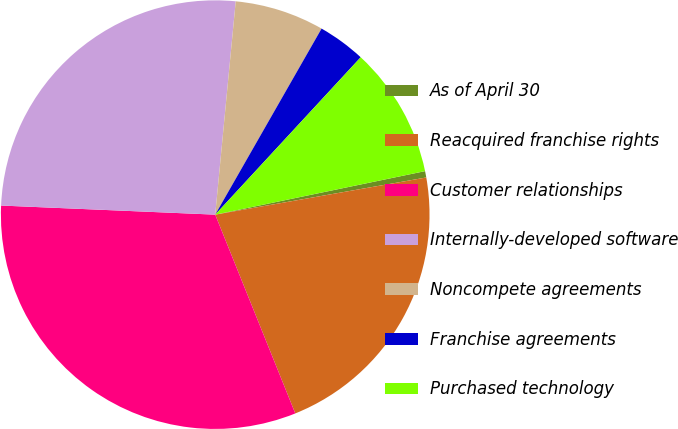Convert chart. <chart><loc_0><loc_0><loc_500><loc_500><pie_chart><fcel>As of April 30<fcel>Reacquired franchise rights<fcel>Customer relationships<fcel>Internally-developed software<fcel>Noncompete agreements<fcel>Franchise agreements<fcel>Purchased technology<nl><fcel>0.48%<fcel>21.68%<fcel>31.77%<fcel>25.85%<fcel>6.74%<fcel>3.61%<fcel>9.87%<nl></chart> 